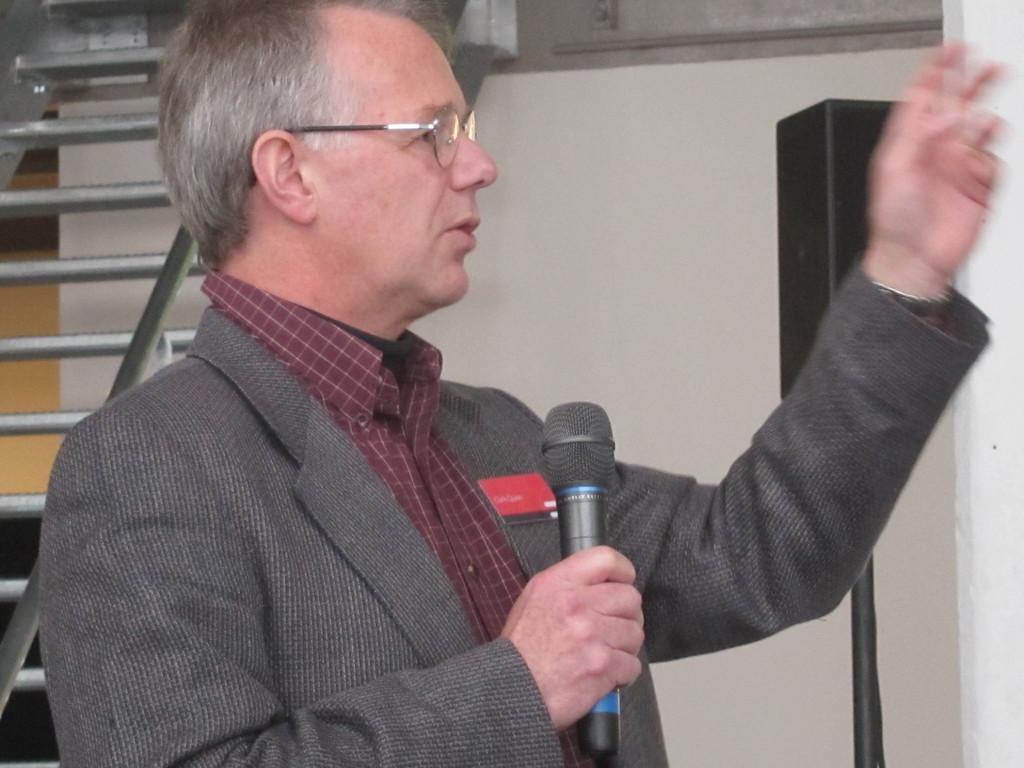Describe this image in one or two sentences. In this image I can see the person wearing the grey color blazer and maroon color shirt. I can see the person holding the mic. To the side of the person I can see the stairs and the black color sound box. In the background I can see the wall. 